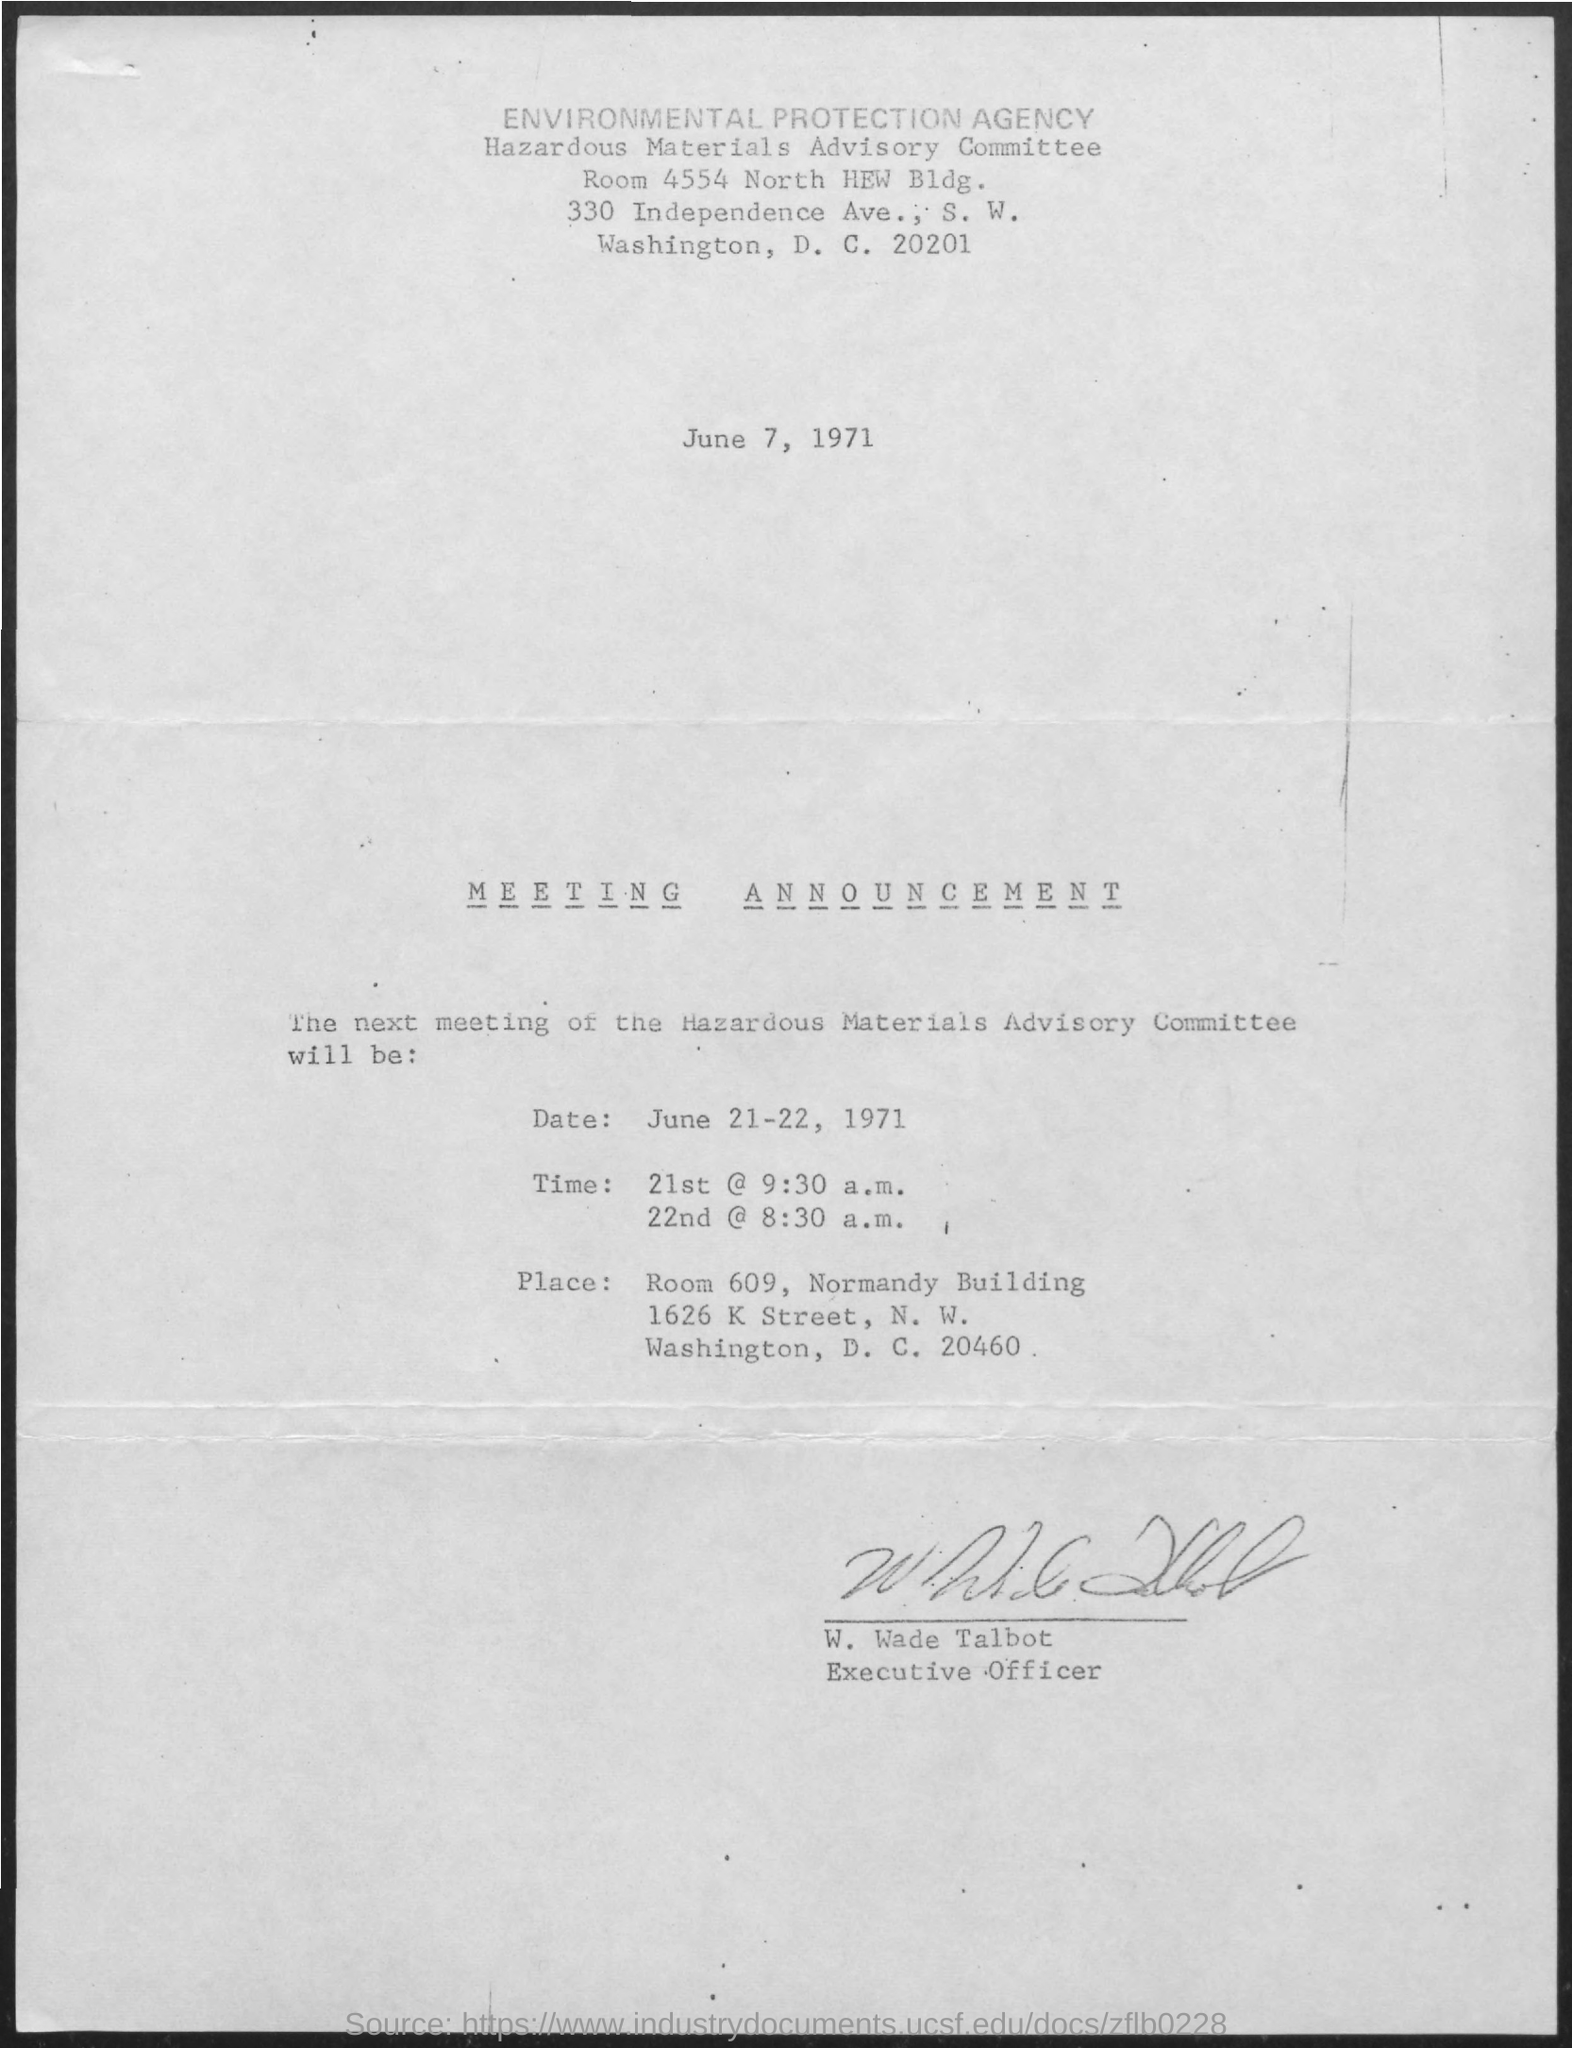When is the meeting of the Hazardous Materials Advisory Committee announced?
Make the answer very short. June 21-22, 1971. Who has signed this document?
Keep it short and to the point. W. Wade Talbot. What is the designation of W. Wade Talbot?
Ensure brevity in your answer.  Executive Officer. What time is the meeting of the Hazardous Materials Advisory Committee announced on 21st June 1971?
Provide a short and direct response. @ 9:30 a.m. What time is the meeting of the Hazardous Materials Advisory Committee announced on 22nd June 1971?
Your response must be concise. 8:30 a.m. 